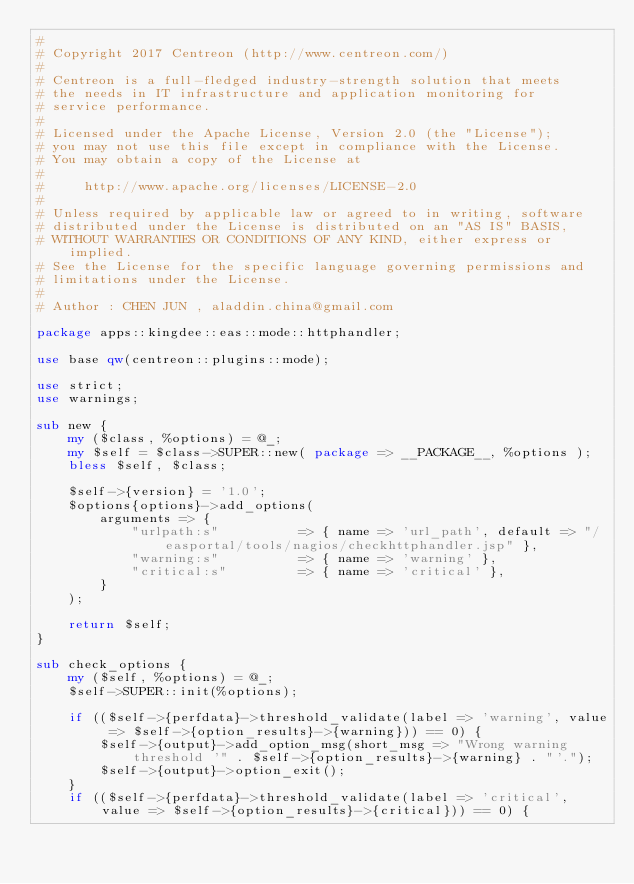Convert code to text. <code><loc_0><loc_0><loc_500><loc_500><_Perl_>#
# Copyright 2017 Centreon (http://www.centreon.com/)
#
# Centreon is a full-fledged industry-strength solution that meets
# the needs in IT infrastructure and application monitoring for
# service performance.
#
# Licensed under the Apache License, Version 2.0 (the "License");
# you may not use this file except in compliance with the License.
# You may obtain a copy of the License at
#
#     http://www.apache.org/licenses/LICENSE-2.0
#
# Unless required by applicable law or agreed to in writing, software
# distributed under the License is distributed on an "AS IS" BASIS,
# WITHOUT WARRANTIES OR CONDITIONS OF ANY KIND, either express or implied.
# See the License for the specific language governing permissions and
# limitations under the License.
#
# Author : CHEN JUN , aladdin.china@gmail.com

package apps::kingdee::eas::mode::httphandler;

use base qw(centreon::plugins::mode);

use strict;
use warnings;

sub new {
    my ($class, %options) = @_;
    my $self = $class->SUPER::new( package => __PACKAGE__, %options );
    bless $self, $class;

    $self->{version} = '1.0';
    $options{options}->add_options(
        arguments => {
            "urlpath:s"          => { name => 'url_path', default => "/easportal/tools/nagios/checkhttphandler.jsp" },
            "warning:s"          => { name => 'warning' },
            "critical:s"         => { name => 'critical' },
        }
    );

    return $self;
}

sub check_options {
    my ($self, %options) = @_;
    $self->SUPER::init(%options);

    if (($self->{perfdata}->threshold_validate(label => 'warning', value => $self->{option_results}->{warning})) == 0) {
        $self->{output}->add_option_msg(short_msg => "Wrong warning threshold '" . $self->{option_results}->{warning} . "'.");
        $self->{output}->option_exit();
    }
    if (($self->{perfdata}->threshold_validate(label => 'critical', value => $self->{option_results}->{critical})) == 0) {</code> 